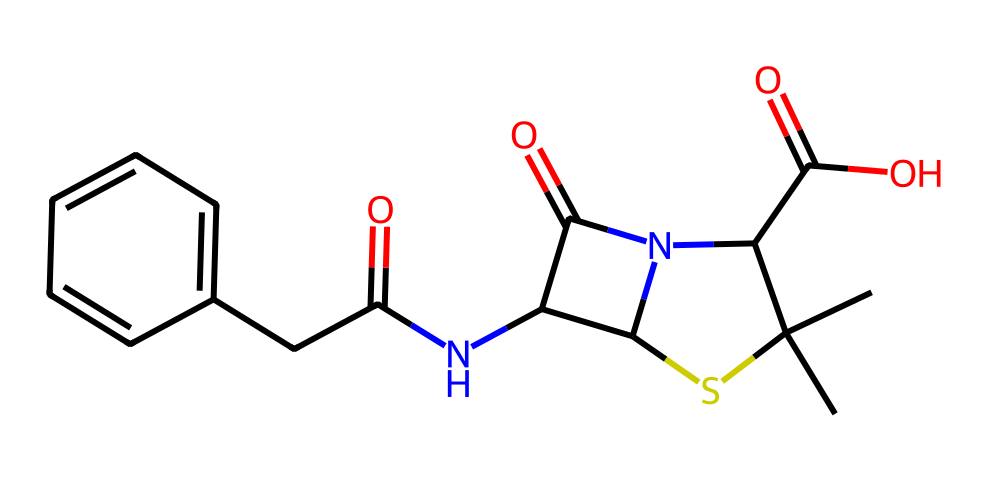What is the molecular formula of this chemical? To find the molecular formula, we can count the number of each type of atom in the SMILES representation. The representation includes carbon (C), hydrogen (H), nitrogen (N), oxygen (O), and sulfur (S). Counting each, we find 14 carbons, 16 hydrogens, 4 nitrogens, 4 oxygens, and 1 sulfur. Therefore, the molecular formula is C14H16N4O4S.
Answer: C14H16N4O4S How many nitrogen atoms are present in the structure? By analyzing the SMILES representation, we can identify the nitrogen atoms. Notably, there are 4 'N' letters in the provided SMILES. Thus, the chemical contains four nitrogen atoms.
Answer: 4 What type of chemical reaction is penicillin primarily involved in? Penicillin primarily acts as a beta-lactam antibiotic, which means it inhibits cell wall synthesis in bacteria. This specific action is due to its ability to interfere with the transpeptidase enzyme, which is crucial for cross-linking peptidoglycan layers in bacterial cell walls.
Answer: antibiotic Which functional groups are evident in this chemical? By examining the structure, we can identify several functional groups: a carboxylic acid group (-COOH), an amide group (-C(=O)N-), and a thiazolidine ring. Each of these groups contributes to the chemical's biological activity and properties.
Answer: carboxylic acid, amide, thiazolidine What is the significance of the sulfur atom in this compound? The sulfur atom in penicillin is part of the thiazolidine ring structure, which is essential for the antibiotic's mechanism of action. The presence of sulfur contributes to the stability and reactivity of the compound against bacterial enzymes, making it effective in treating infections.
Answer: thiazolidine ring How does the structure of penicillin relate to its effectiveness as an antibiotic? The unique beta-lactam structure in penicillin allows it to bind to penicillin-binding proteins (PBPs) and inhibit their function, which is critical for bacterial cell wall synthesis. This inhibition leads to cell lysis and the death of the bacteria, indicating its mechanism as an antibiotic.
Answer: beta-lactam structure 